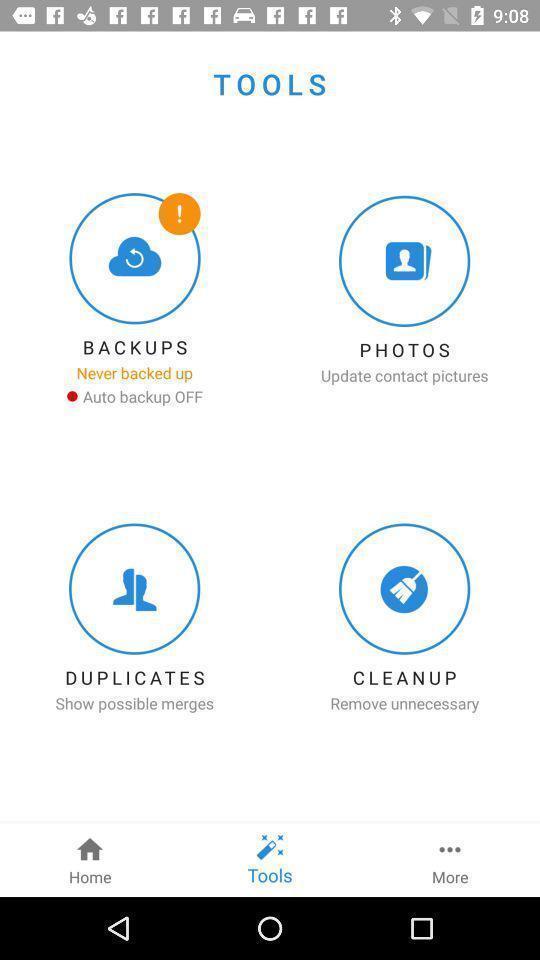Give me a summary of this screen capture. Screen showing tools. 